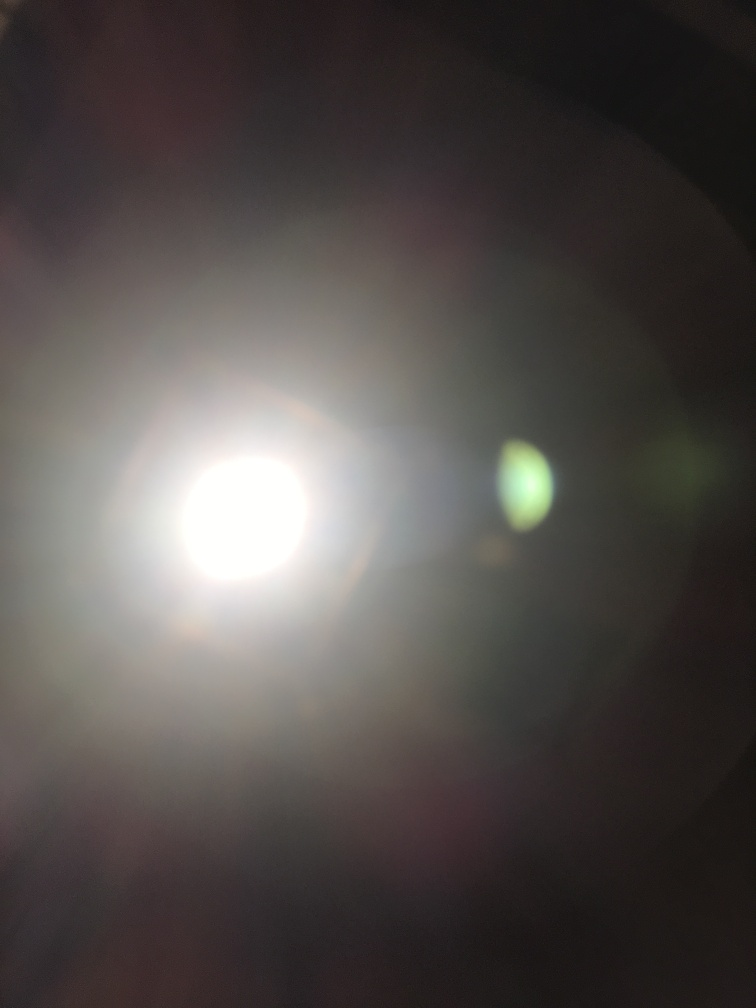Can you guess what might be causing the bright light in this image? It's difficult to determine the exact source of the bright light due to overexposure. However, it may be sunlight reflecting off a surface, a camera flash, or another type of artificial light. The glare and lens flare effects suggest a strong light source directly facing the camera lens. Is there anything that can be done to improve a photo like this one? To improve a photo like this, one should adjust the camera settings to avoid overexposure. Lowering the ISO setting, reducing the exposure time (faster shutter speed), and narrowing the aperture (higher f-stop number) can help. Additionally, changing the angle of the camera to prevent direct light from hitting the lens or using a lens hood could prevent such glare. 